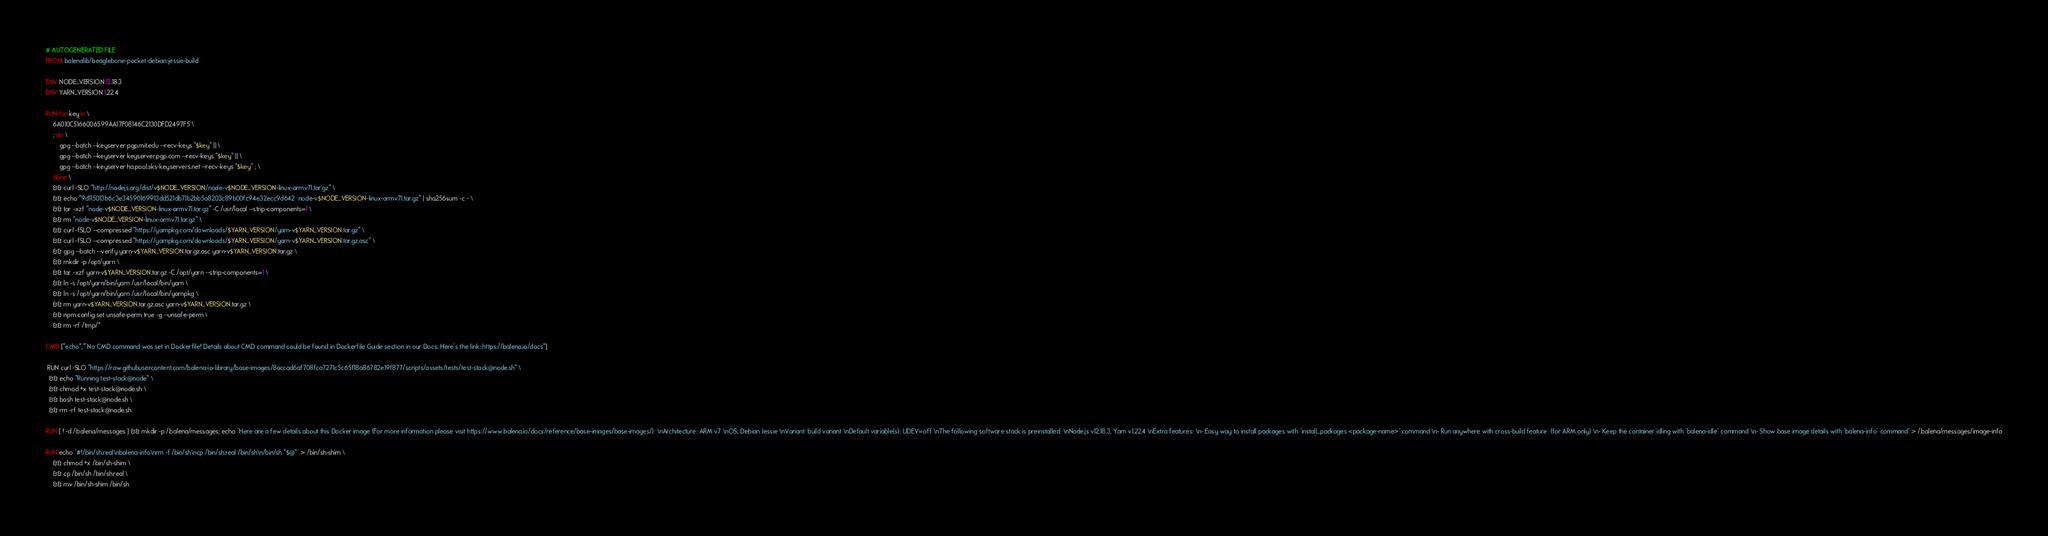<code> <loc_0><loc_0><loc_500><loc_500><_Dockerfile_># AUTOGENERATED FILE
FROM balenalib/beaglebone-pocket-debian:jessie-build

ENV NODE_VERSION 12.18.3
ENV YARN_VERSION 1.22.4

RUN for key in \
	6A010C5166006599AA17F08146C2130DFD2497F5 \
	; do \
		gpg --batch --keyserver pgp.mit.edu --recv-keys "$key" || \
		gpg --batch --keyserver keyserver.pgp.com --recv-keys "$key" || \
		gpg --batch --keyserver ha.pool.sks-keyservers.net --recv-keys "$key" ; \
	done \
	&& curl -SLO "http://nodejs.org/dist/v$NODE_VERSION/node-v$NODE_VERSION-linux-armv7l.tar.gz" \
	&& echo "9d115013b6c3e34590169913dd521db71b2bb5a8203c89b00fc94e32ecc9d642  node-v$NODE_VERSION-linux-armv7l.tar.gz" | sha256sum -c - \
	&& tar -xzf "node-v$NODE_VERSION-linux-armv7l.tar.gz" -C /usr/local --strip-components=1 \
	&& rm "node-v$NODE_VERSION-linux-armv7l.tar.gz" \
	&& curl -fSLO --compressed "https://yarnpkg.com/downloads/$YARN_VERSION/yarn-v$YARN_VERSION.tar.gz" \
	&& curl -fSLO --compressed "https://yarnpkg.com/downloads/$YARN_VERSION/yarn-v$YARN_VERSION.tar.gz.asc" \
	&& gpg --batch --verify yarn-v$YARN_VERSION.tar.gz.asc yarn-v$YARN_VERSION.tar.gz \
	&& mkdir -p /opt/yarn \
	&& tar -xzf yarn-v$YARN_VERSION.tar.gz -C /opt/yarn --strip-components=1 \
	&& ln -s /opt/yarn/bin/yarn /usr/local/bin/yarn \
	&& ln -s /opt/yarn/bin/yarn /usr/local/bin/yarnpkg \
	&& rm yarn-v$YARN_VERSION.tar.gz.asc yarn-v$YARN_VERSION.tar.gz \
	&& npm config set unsafe-perm true -g --unsafe-perm \
	&& rm -rf /tmp/*

CMD ["echo","'No CMD command was set in Dockerfile! Details about CMD command could be found in Dockerfile Guide section in our Docs. Here's the link: https://balena.io/docs"]

 RUN curl -SLO "https://raw.githubusercontent.com/balena-io-library/base-images/8accad6af708fca7271c5c65f18a86782e19f877/scripts/assets/tests/test-stack@node.sh" \
  && echo "Running test-stack@node" \
  && chmod +x test-stack@node.sh \
  && bash test-stack@node.sh \
  && rm -rf test-stack@node.sh 

RUN [ ! -d /.balena/messages ] && mkdir -p /.balena/messages; echo 'Here are a few details about this Docker image (For more information please visit https://www.balena.io/docs/reference/base-images/base-images/): \nArchitecture: ARM v7 \nOS: Debian Jessie \nVariant: build variant \nDefault variable(s): UDEV=off \nThe following software stack is preinstalled: \nNode.js v12.18.3, Yarn v1.22.4 \nExtra features: \n- Easy way to install packages with `install_packages <package-name>` command \n- Run anywhere with cross-build feature  (for ARM only) \n- Keep the container idling with `balena-idle` command \n- Show base image details with `balena-info` command' > /.balena/messages/image-info

RUN echo '#!/bin/sh.real\nbalena-info\nrm -f /bin/sh\ncp /bin/sh.real /bin/sh\n/bin/sh "$@"' > /bin/sh-shim \
	&& chmod +x /bin/sh-shim \
	&& cp /bin/sh /bin/sh.real \
	&& mv /bin/sh-shim /bin/sh</code> 